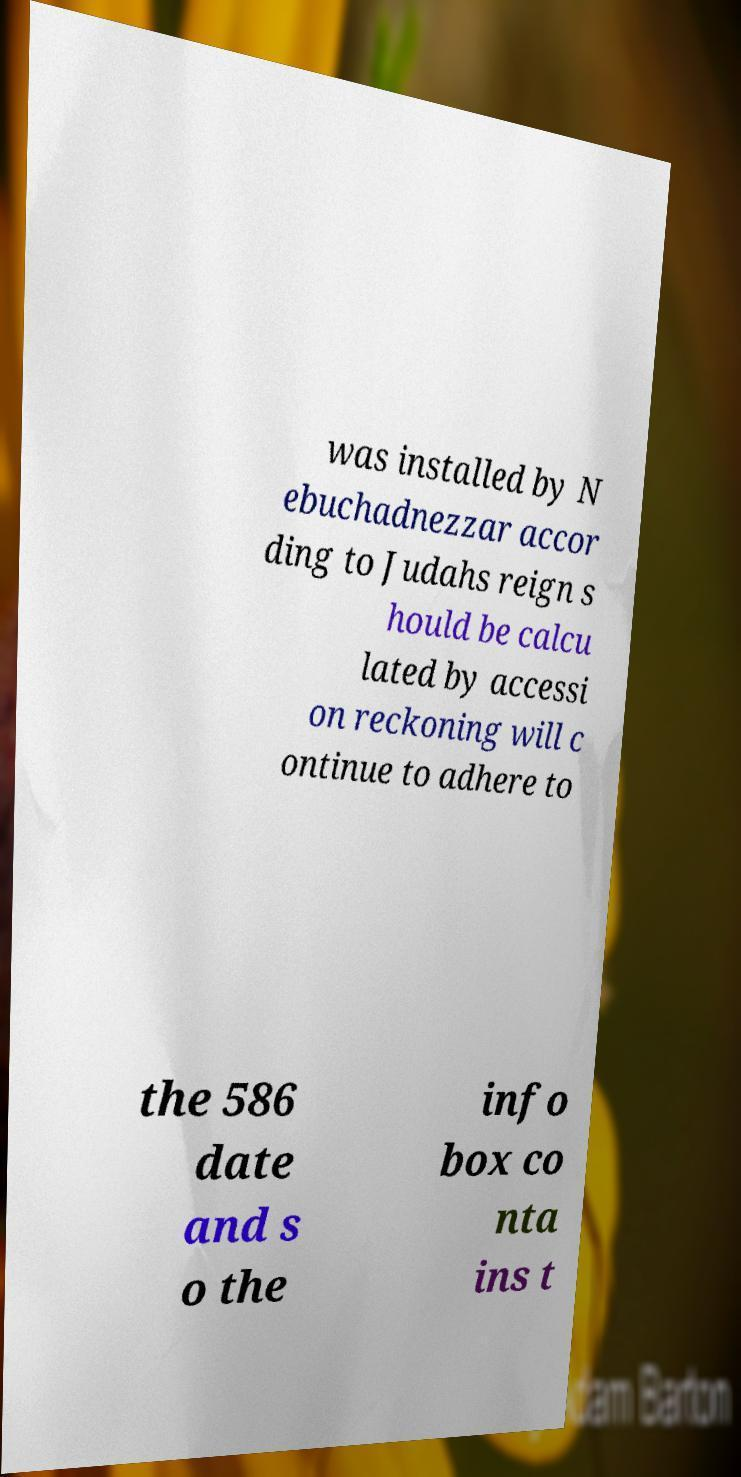Please identify and transcribe the text found in this image. was installed by N ebuchadnezzar accor ding to Judahs reign s hould be calcu lated by accessi on reckoning will c ontinue to adhere to the 586 date and s o the info box co nta ins t 